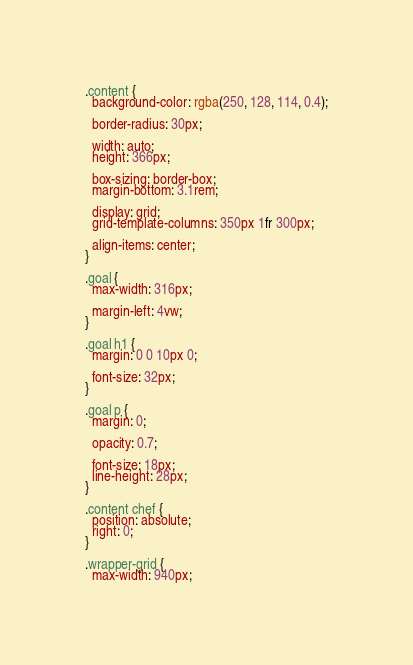Convert code to text. <code><loc_0><loc_0><loc_500><loc_500><_CSS_>.content {
  background-color: rgba(250, 128, 114, 0.4);

  border-radius: 30px;

  width: auto;
  height: 366px;

  box-sizing: border-box;
  margin-bottom: 3.1rem;

  display: grid;
  grid-template-columns: 350px 1fr 300px;

  align-items: center;
}

.goal {
  max-width: 316px;

  margin-left: 4vw;
}

.goal h1 {
  margin: 0 0 10px 0;

  font-size: 32px;
}

.goal p {
  margin: 0;

  opacity: 0.7;

  font-size: 18px;
  line-height: 28px;
}

.content chef {
  position: absolute;
  right: 0;
}

.wrapper-grid {
  max-width: 940px;</code> 